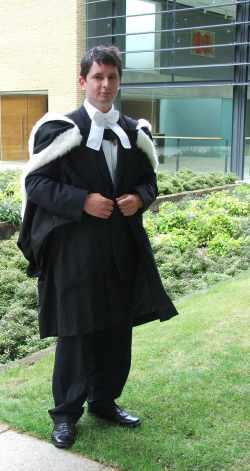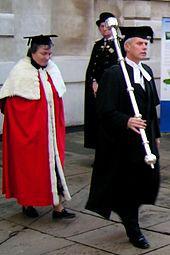The first image is the image on the left, the second image is the image on the right. For the images displayed, is the sentence "The left image contains no more than two graduation students." factually correct? Answer yes or no. Yes. The first image is the image on the left, the second image is the image on the right. Analyze the images presented: Is the assertion "An image contains one front-facing graduate, a young man wearing a white bow around his neck and no cap." valid? Answer yes or no. Yes. 